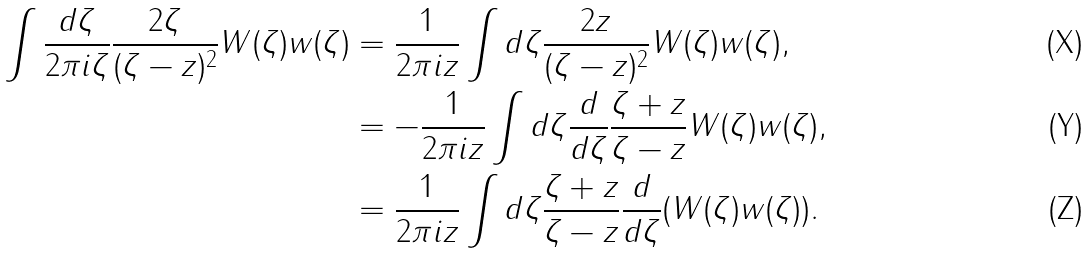Convert formula to latex. <formula><loc_0><loc_0><loc_500><loc_500>\int \frac { d \zeta } { 2 \pi i \zeta } \frac { 2 \zeta } { ( \zeta - z ) ^ { 2 } } W ( \zeta ) w ( \zeta ) & = \frac { 1 } { 2 \pi i z } \int d \zeta \frac { 2 z } { ( \zeta - z ) ^ { 2 } } W ( \zeta ) w ( \zeta ) , \\ & = - \frac { 1 } { 2 \pi i z } \int d \zeta \frac { d } { d \zeta } \frac { \zeta + z } { \zeta - z } W ( \zeta ) w ( \zeta ) , \\ & = \frac { 1 } { 2 \pi i z } \int d \zeta \frac { \zeta + z } { \zeta - z } \frac { d } { d \zeta } ( W ( \zeta ) w ( \zeta ) ) .</formula> 